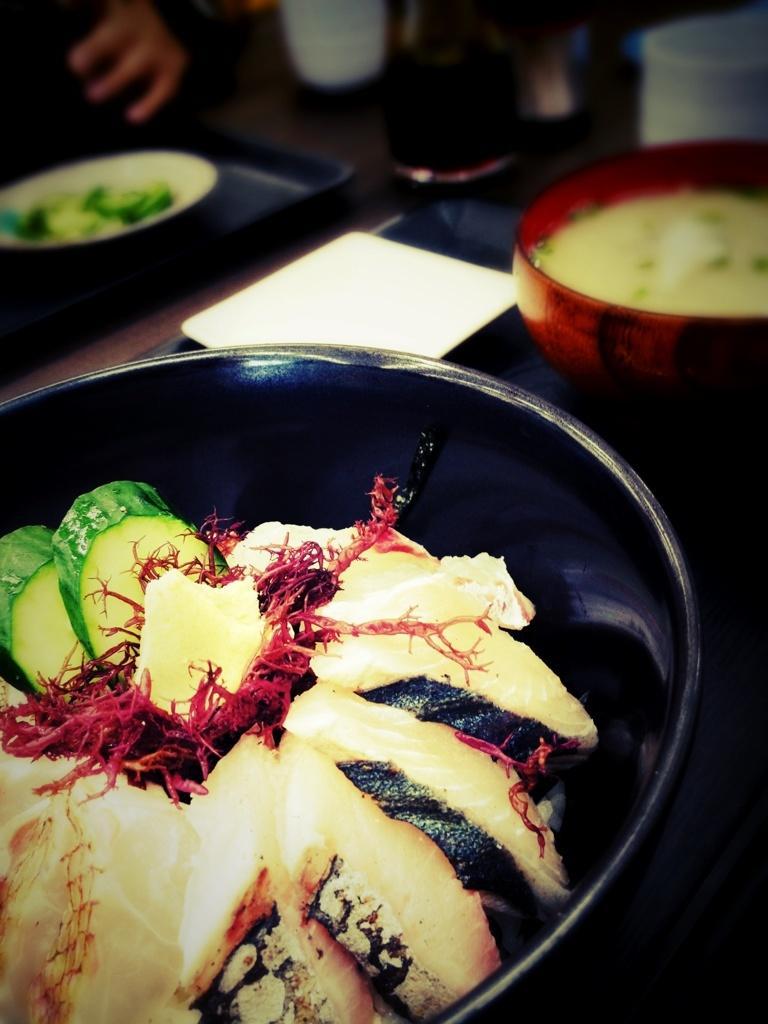Can you describe this image briefly? In this image, we can see food items in the bowl. Top of the image, there is a blur view. Here we can see bowl with food, plate, tray, few objects. 